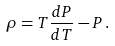Convert formula to latex. <formula><loc_0><loc_0><loc_500><loc_500>\rho = T \frac { d P } { d T } - P \, .</formula> 